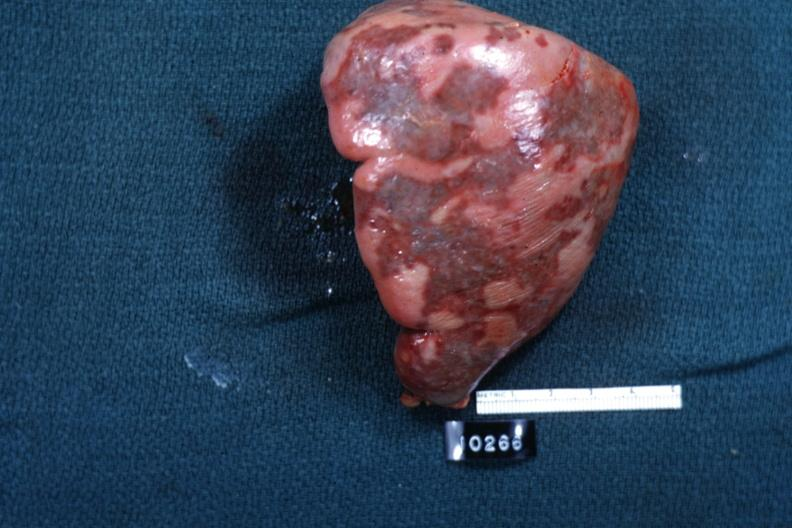what is surface?
Answer the question using a single word or phrase. Slide 